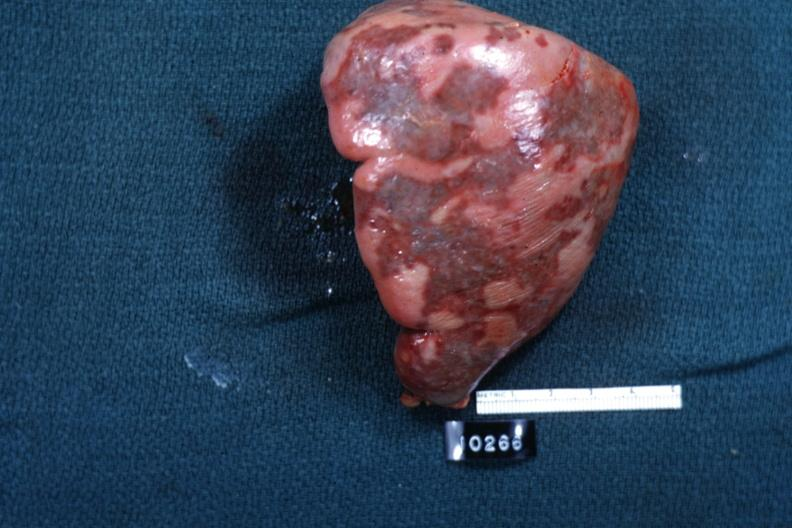what is surface?
Answer the question using a single word or phrase. Slide 